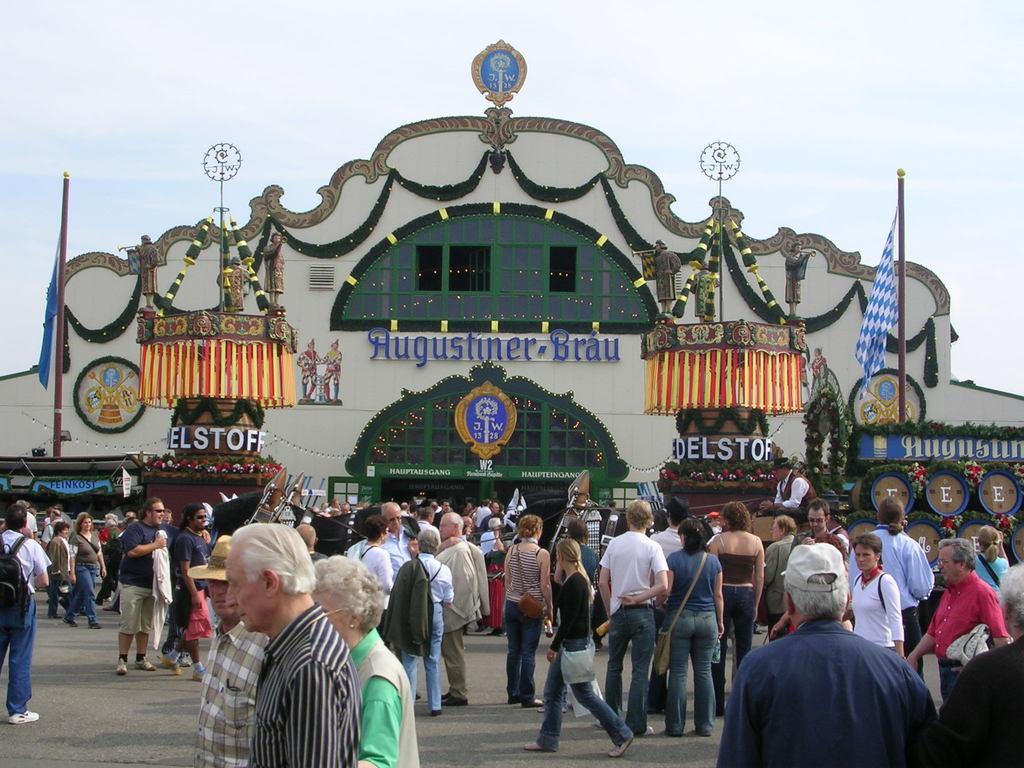Can you describe this image briefly? In this image there are people standing on a floor, in the background there is a building and flagpoles. 